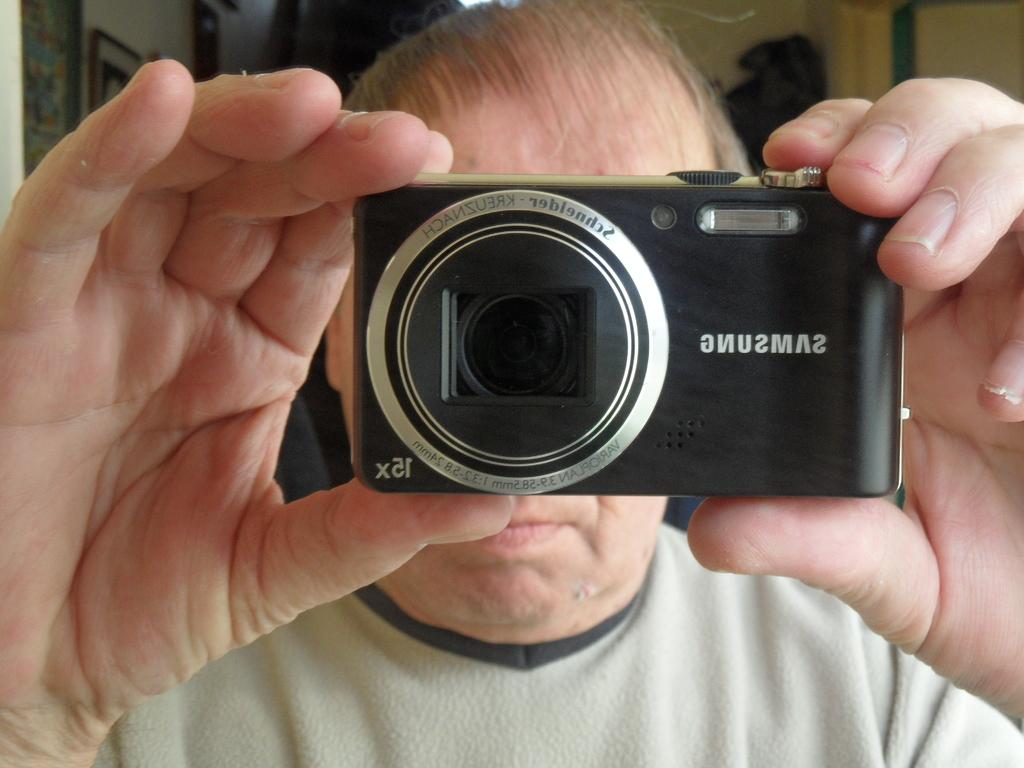Who is present in the image? There is a person in the image. What is the person holding in the image? The person is holding a camera. What can be seen on the wall in the background of the image? There are photo frames on the wall in the background of the image. What type of attack is being carried out in the image? There is no attack present in the image; it features a person holding a camera and photo frames on the wall. What day is it in the image? The image does not depict a specific day; it is a still photograph. 